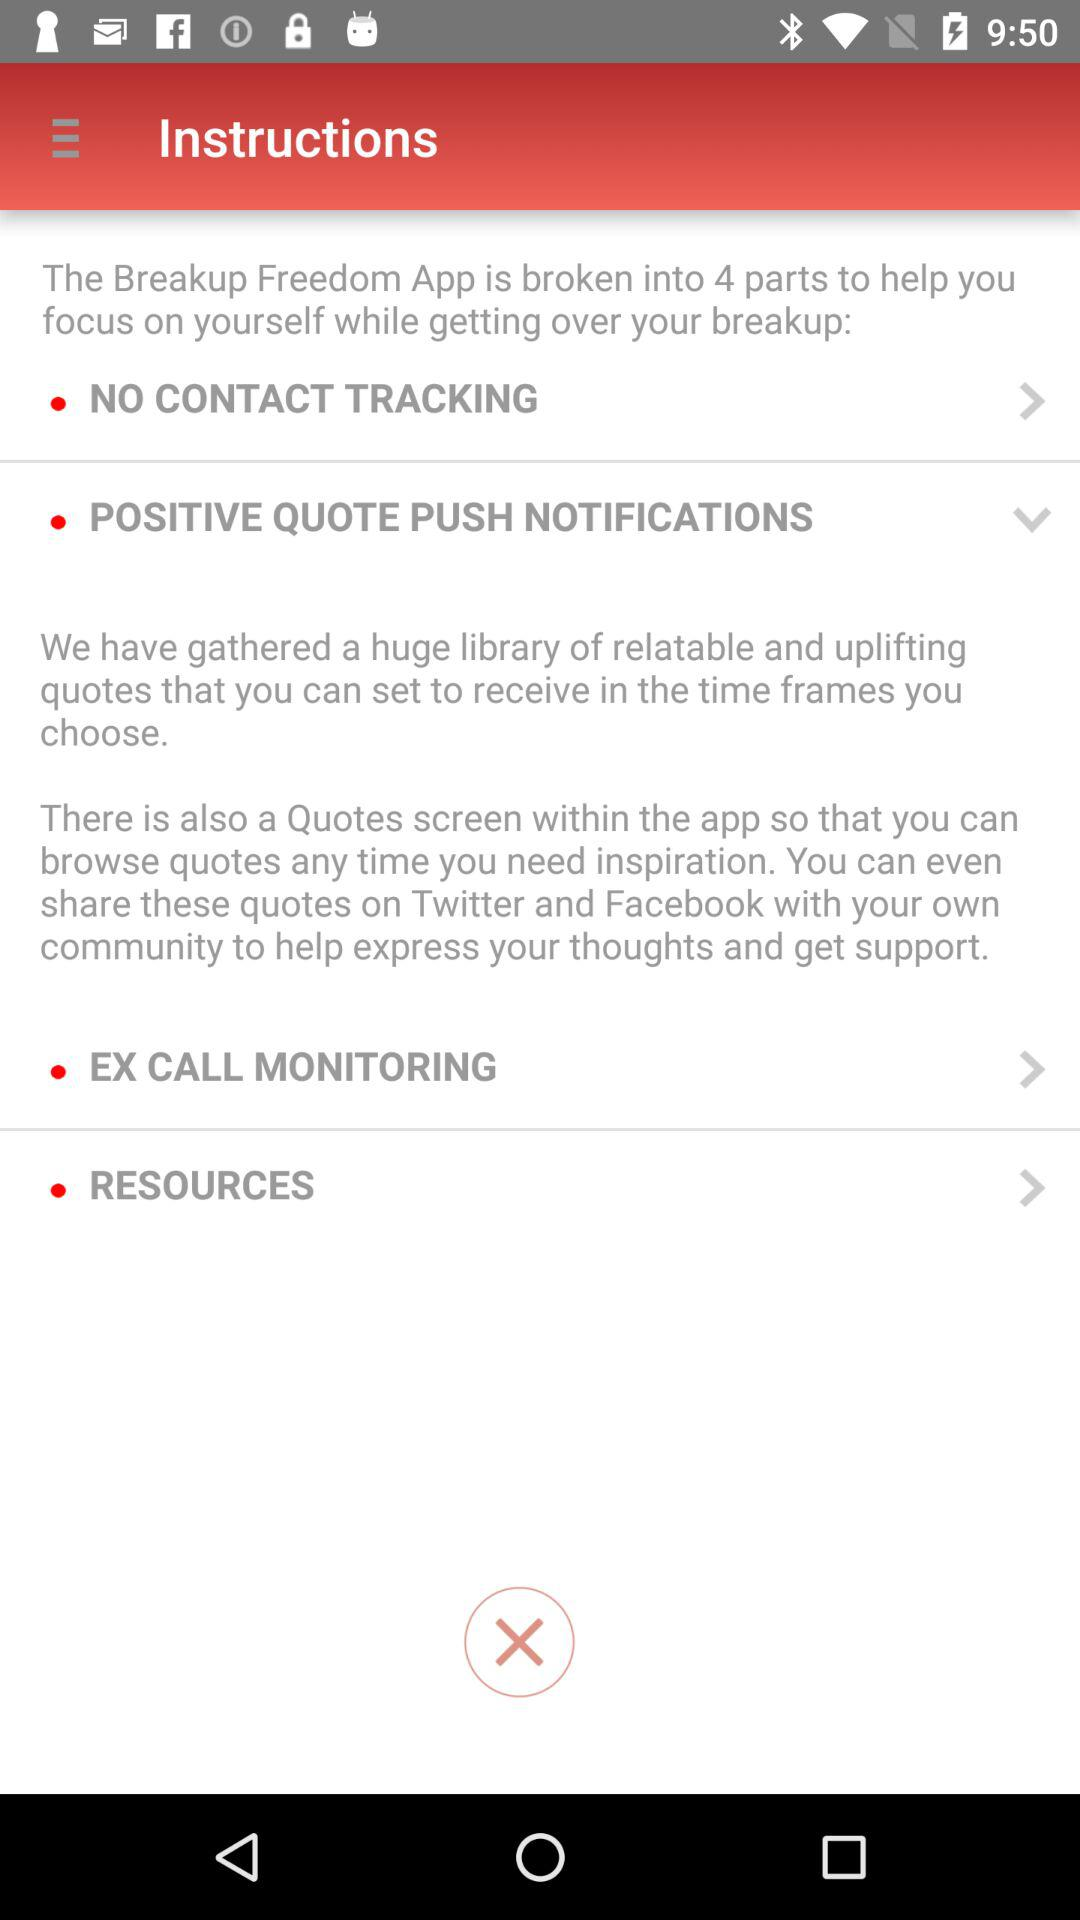How many parts is the application divided into? The application is divided into 4 parts. 